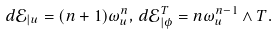Convert formula to latex. <formula><loc_0><loc_0><loc_500><loc_500>d \mathcal { E } _ { | u } = ( n + 1 ) \omega _ { u } ^ { n } , \, d \mathcal { E } _ { | \phi } ^ { T } = n \omega _ { u } ^ { n - 1 } \wedge T .</formula> 